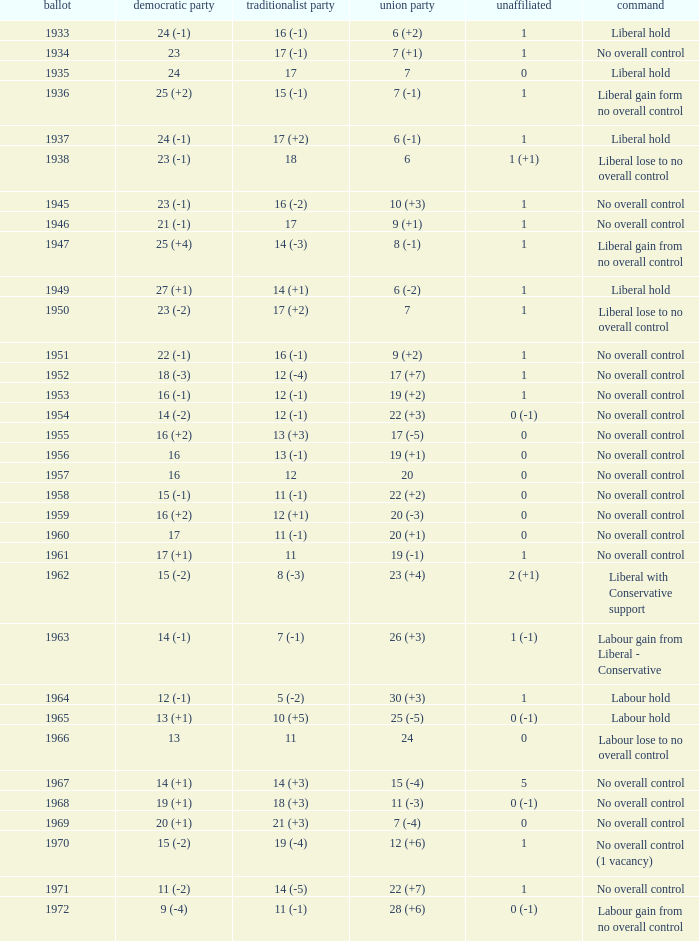What was the control for the year with a Conservative Party result of 10 (+5)? Labour hold. 